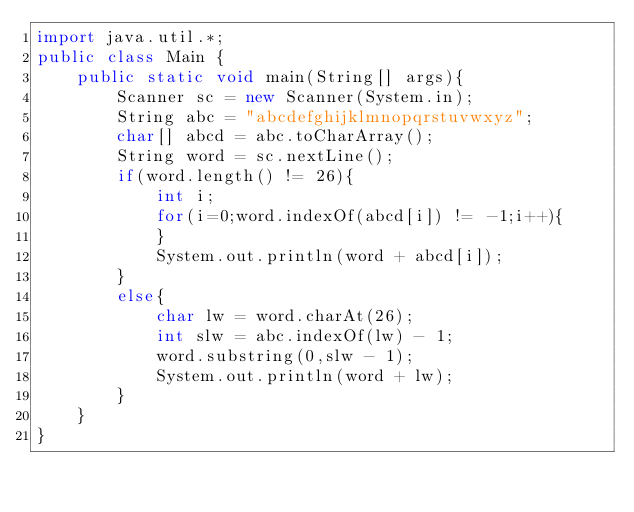Convert code to text. <code><loc_0><loc_0><loc_500><loc_500><_Java_>import java.util.*;
public class Main {
	  public static void main(String[] args){
		    Scanner sc = new Scanner(System.in);
        String abc = "abcdefghijklmnopqrstuvwxyz";
        char[] abcd = abc.toCharArray();
				String word = sc.nextLine();
        if(word.length() != 26){
            int i;
            for(i=0;word.indexOf(abcd[i]) != -1;i++){
            }
            System.out.println(word + abcd[i]);
        }
        else{
            char lw = word.charAt(26);
            int slw = abc.indexOf(lw) - 1;
            word.substring(0,slw - 1);
            System.out.println(word + lw);
        }
    }
}
</code> 